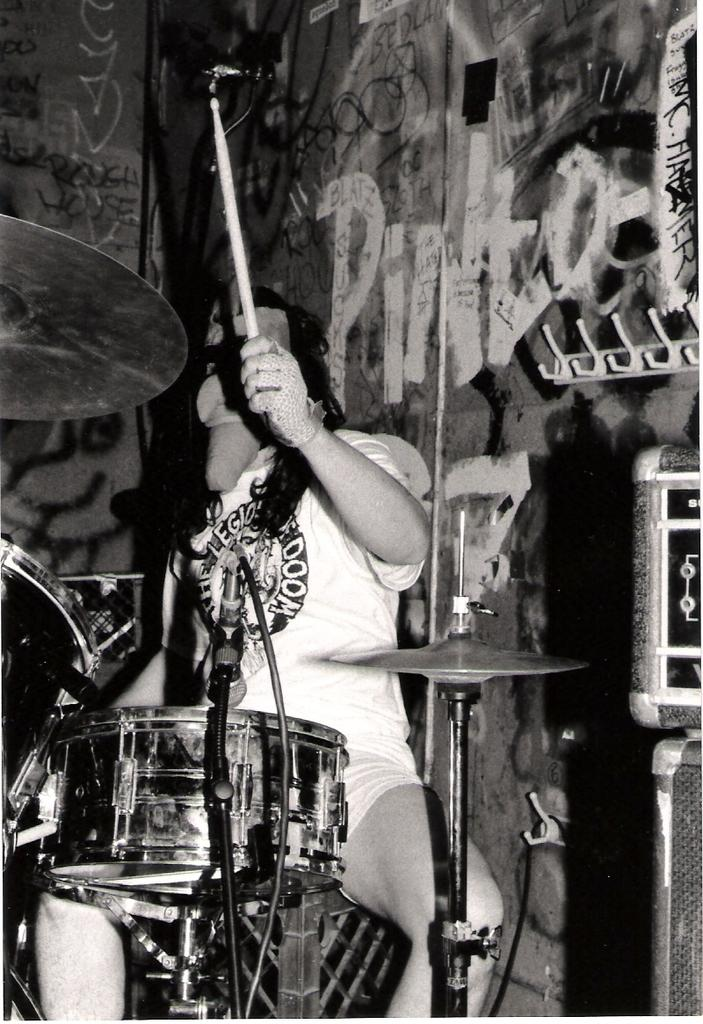What is the person in the image doing? The person is playing a drum. How is the person playing the drum? The person is using a stick to play the drum. What can be seen in the background of the image? There is a wall in the background of the image. What type of trouble is the cub causing in the image? There is no cub present in the image, so it is not possible to determine if any trouble is being caused. 